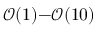<formula> <loc_0><loc_0><loc_500><loc_500>\mathcal { O } ( 1 ) { - } \mathcal { O } ( 1 0 )</formula> 